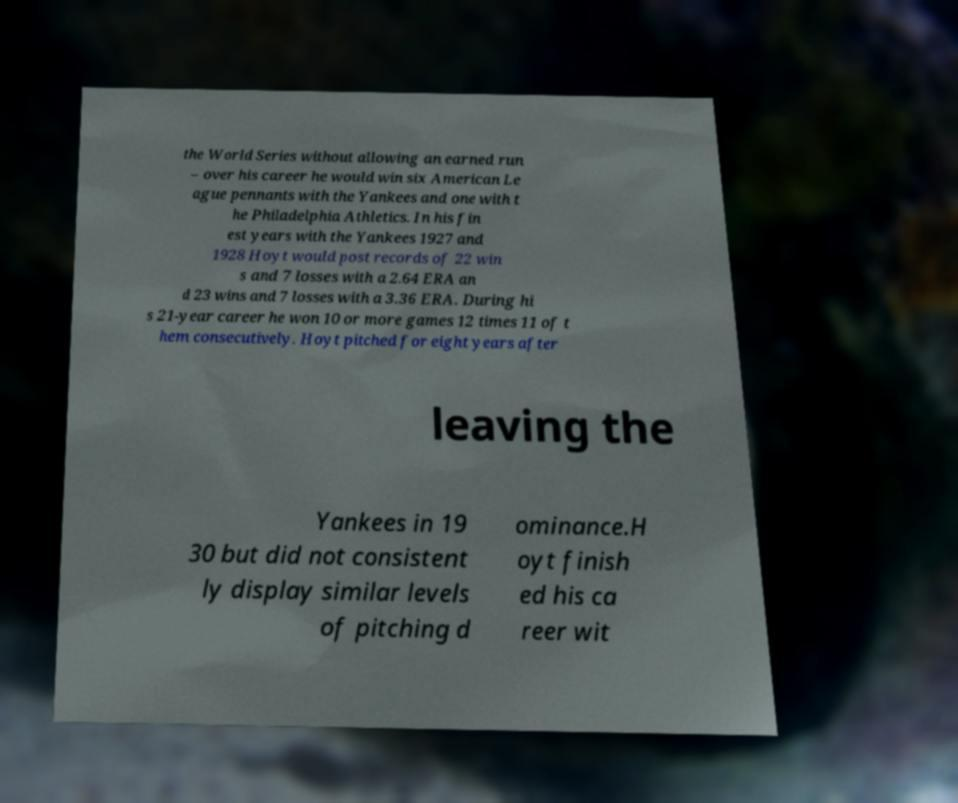Could you extract and type out the text from this image? the World Series without allowing an earned run – over his career he would win six American Le ague pennants with the Yankees and one with t he Philadelphia Athletics. In his fin est years with the Yankees 1927 and 1928 Hoyt would post records of 22 win s and 7 losses with a 2.64 ERA an d 23 wins and 7 losses with a 3.36 ERA. During hi s 21-year career he won 10 or more games 12 times 11 of t hem consecutively. Hoyt pitched for eight years after leaving the Yankees in 19 30 but did not consistent ly display similar levels of pitching d ominance.H oyt finish ed his ca reer wit 